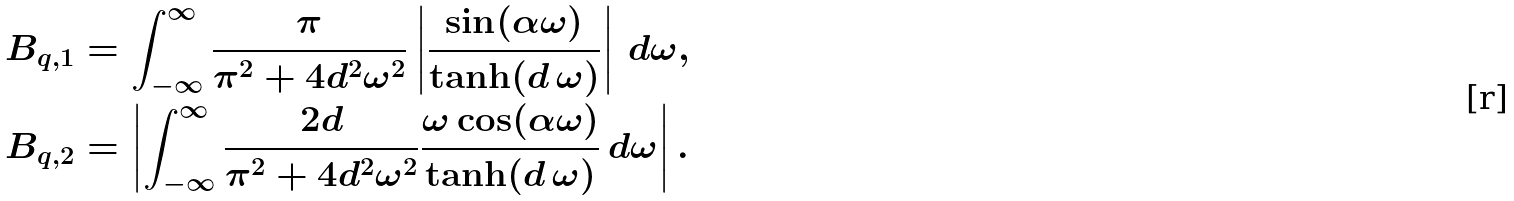<formula> <loc_0><loc_0><loc_500><loc_500>B _ { q , 1 } & = \int _ { - \infty } ^ { \infty } \frac { \pi } { \pi ^ { 2 } + 4 d ^ { 2 } \omega ^ { 2 } } \left | \frac { \sin ( \alpha \omega ) } { \tanh ( d \, \omega ) } \right | \, d \omega , \\ B _ { q , 2 } & = \left | \int _ { - \infty } ^ { \infty } \frac { 2 d } { \pi ^ { 2 } + 4 d ^ { 2 } \omega ^ { 2 } } \frac { \omega \cos ( \alpha \omega ) } { \tanh ( d \, \omega ) } \, d \omega \right | .</formula> 